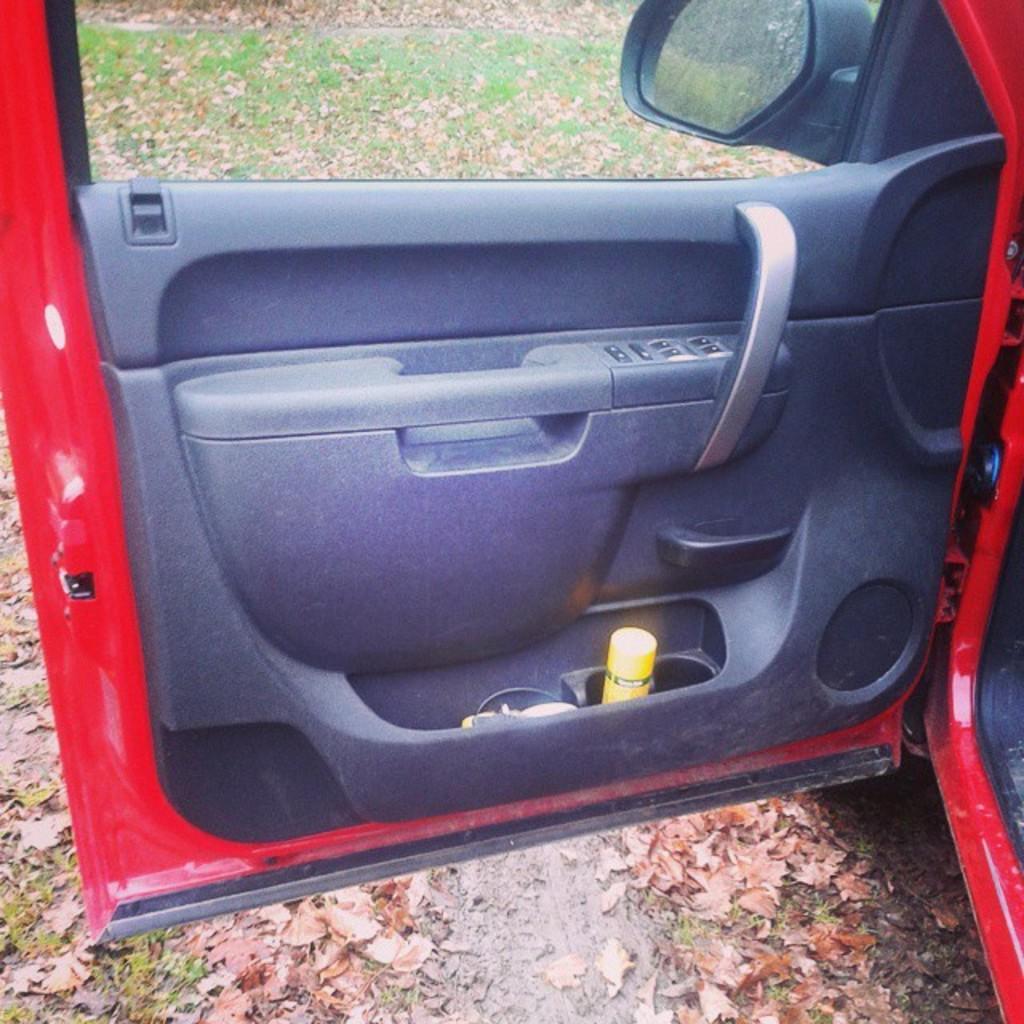Describe this image in one or two sentences. In this image we can see a car door which is of red color and there is spray and some other items in the door, at the background of the image there is side mirror and door. 